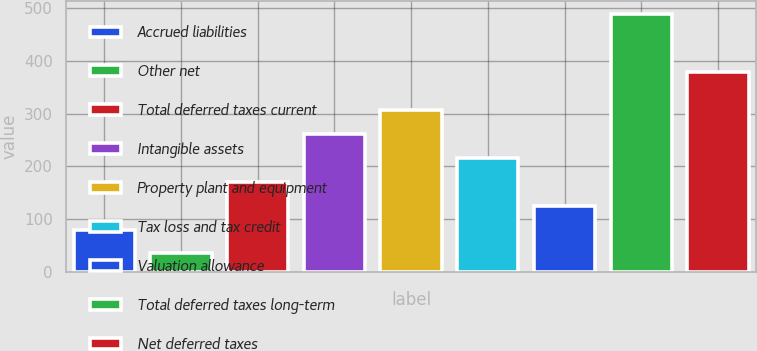Convert chart to OTSL. <chart><loc_0><loc_0><loc_500><loc_500><bar_chart><fcel>Accrued liabilities<fcel>Other net<fcel>Total deferred taxes current<fcel>Intangible assets<fcel>Property plant and equipment<fcel>Tax loss and tax credit<fcel>Valuation allowance<fcel>Total deferred taxes long-term<fcel>Net deferred taxes<nl><fcel>80.47<fcel>35.1<fcel>171.21<fcel>261.95<fcel>307.32<fcel>216.58<fcel>125.84<fcel>488.8<fcel>378.4<nl></chart> 